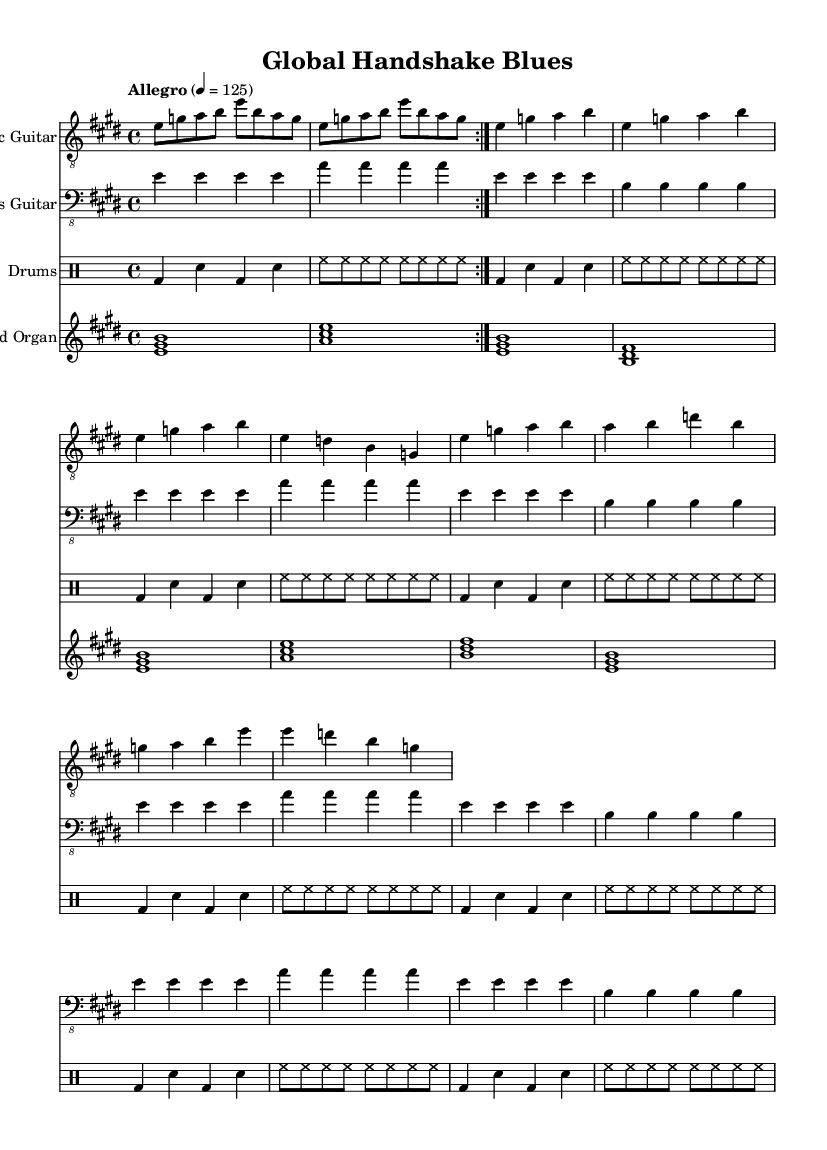What is the key signature of this music? The key signature is E major, which has four sharps: F#, C#, G#, and D#. This can be identified by the key signature notation at the beginning of the sheet music.
Answer: E major What is the time signature of this music? The time signature is 4/4, which indicates there are four beats in each measure and a quarter note gets one beat. This can be found in the measure signature notation present at the beginning of the sheet music.
Answer: 4/4 What is the tempo of this music? The tempo marking reads "Allegro" with a metronome setting of 125. This means the piece should be played quickly, at a speed of 125 beats per minute. The tempo is specified at the beginning of the score.
Answer: Allegro, 125 How many times is the guitar riff repeated in the intro? The guitar riff is repeated 2 times, as indicated by the volta section in the music where the text specifies to repeat the section.
Answer: 2 times What instruments are present in this sheet music? The sheet music features Electric Guitar, Bass Guitar, Drums, and Hammond Organ. Each instrument has its own staff labeled accordingly, which can be seen at the start of each part.
Answer: Electric Guitar, Bass Guitar, Drums, Hammond Organ What theme does the chorus emphasize? The chorus emphasizes success and cultural connectivity, highlighting themes like bridging cultures and making friends as part of global business practices. This can be understood through the lyrics presented in the chorus section of the score.
Answer: Success, bridging cultures 